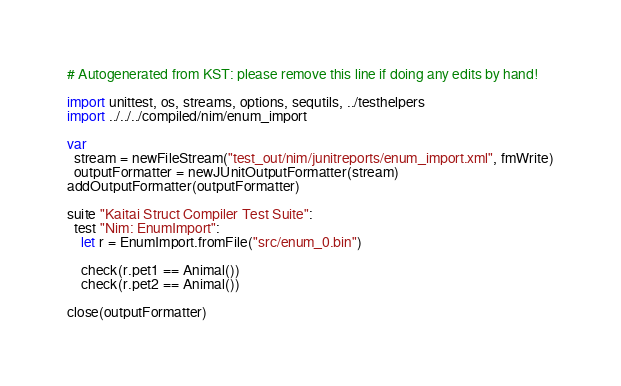Convert code to text. <code><loc_0><loc_0><loc_500><loc_500><_Nim_># Autogenerated from KST: please remove this line if doing any edits by hand!

import unittest, os, streams, options, sequtils, ../testhelpers
import ../../../compiled/nim/enum_import

var
  stream = newFileStream("test_out/nim/junitreports/enum_import.xml", fmWrite)
  outputFormatter = newJUnitOutputFormatter(stream)
addOutputFormatter(outputFormatter)

suite "Kaitai Struct Compiler Test Suite":
  test "Nim: EnumImport":
    let r = EnumImport.fromFile("src/enum_0.bin")

    check(r.pet1 == Animal())
    check(r.pet2 == Animal())

close(outputFormatter)
</code> 